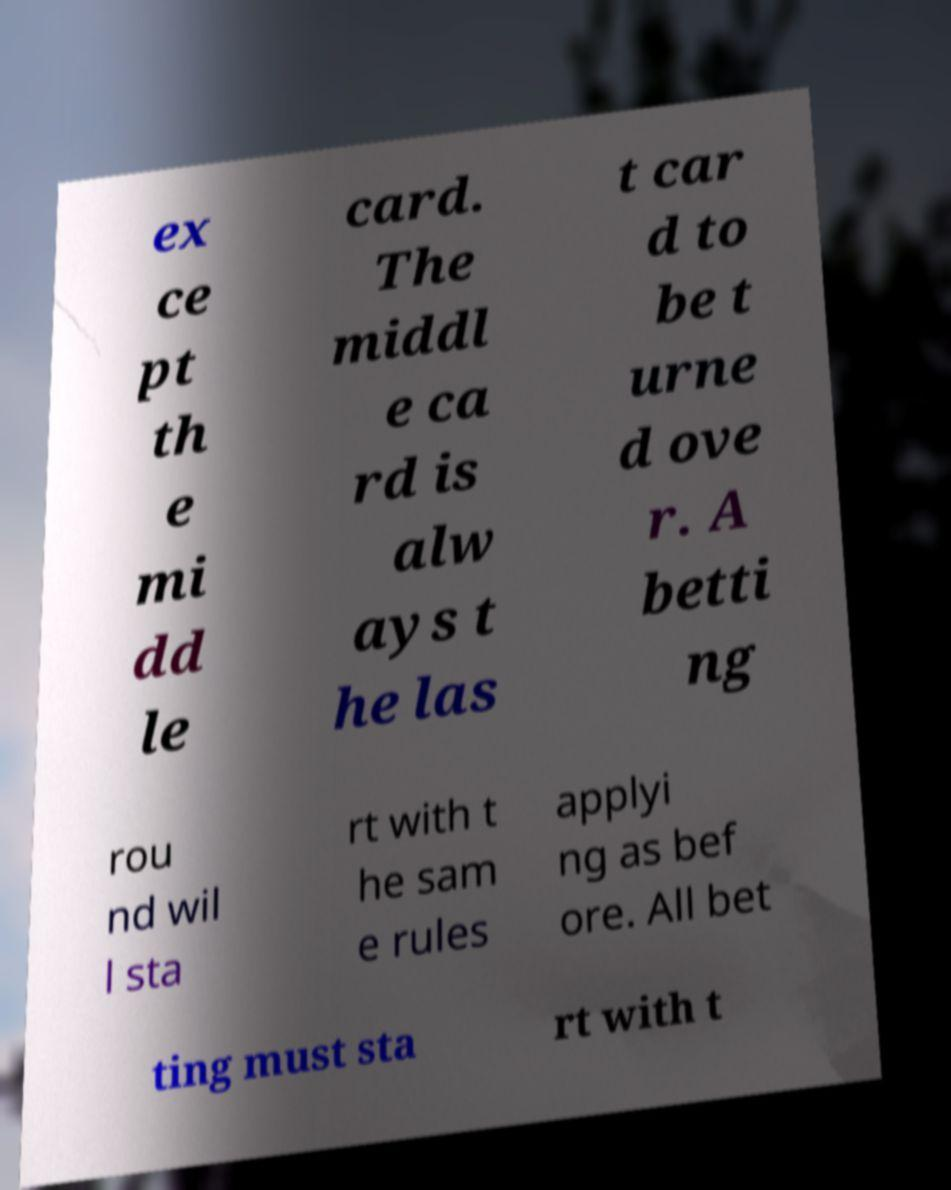Could you assist in decoding the text presented in this image and type it out clearly? ex ce pt th e mi dd le card. The middl e ca rd is alw ays t he las t car d to be t urne d ove r. A betti ng rou nd wil l sta rt with t he sam e rules applyi ng as bef ore. All bet ting must sta rt with t 